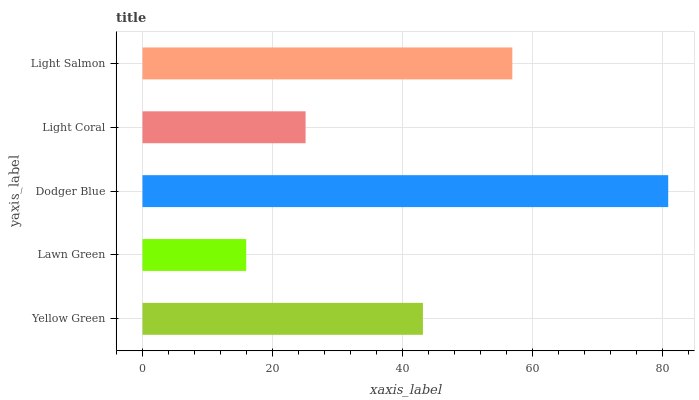Is Lawn Green the minimum?
Answer yes or no. Yes. Is Dodger Blue the maximum?
Answer yes or no. Yes. Is Dodger Blue the minimum?
Answer yes or no. No. Is Lawn Green the maximum?
Answer yes or no. No. Is Dodger Blue greater than Lawn Green?
Answer yes or no. Yes. Is Lawn Green less than Dodger Blue?
Answer yes or no. Yes. Is Lawn Green greater than Dodger Blue?
Answer yes or no. No. Is Dodger Blue less than Lawn Green?
Answer yes or no. No. Is Yellow Green the high median?
Answer yes or no. Yes. Is Yellow Green the low median?
Answer yes or no. Yes. Is Light Salmon the high median?
Answer yes or no. No. Is Lawn Green the low median?
Answer yes or no. No. 